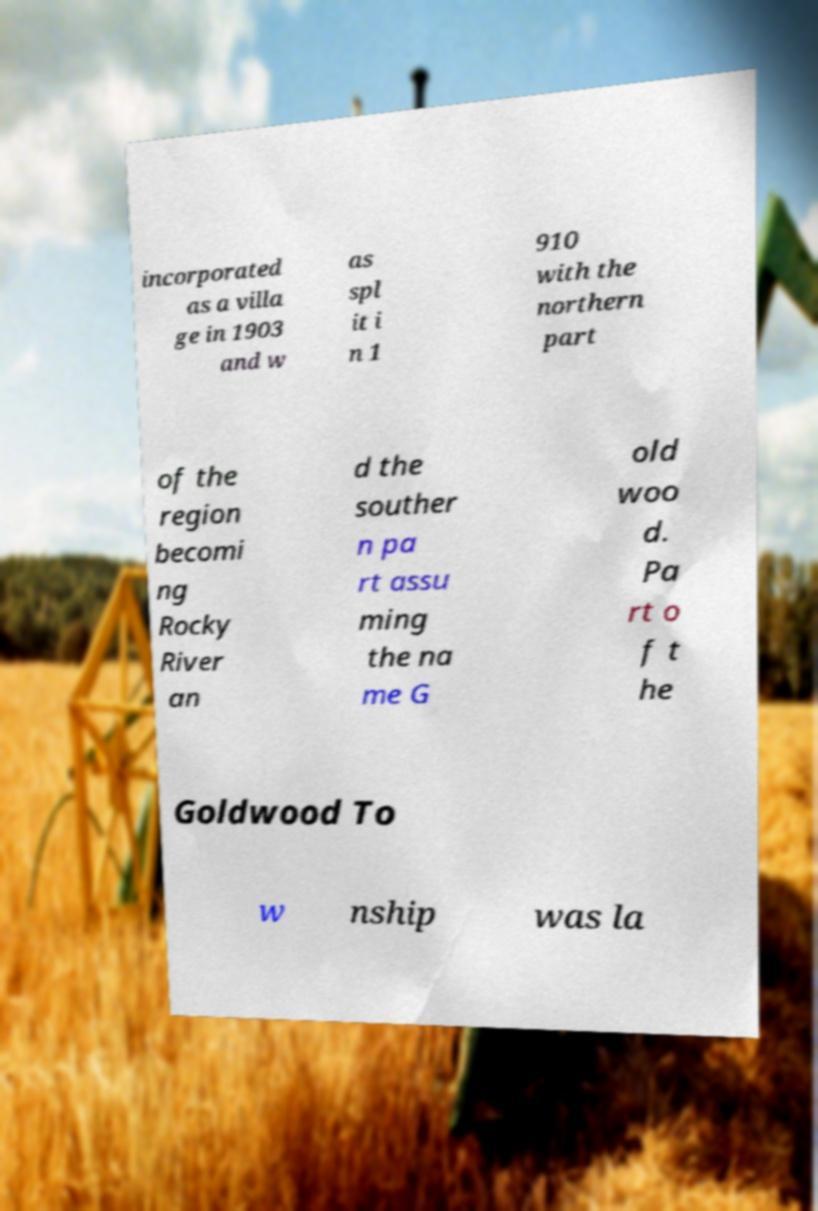I need the written content from this picture converted into text. Can you do that? incorporated as a villa ge in 1903 and w as spl it i n 1 910 with the northern part of the region becomi ng Rocky River an d the souther n pa rt assu ming the na me G old woo d. Pa rt o f t he Goldwood To w nship was la 